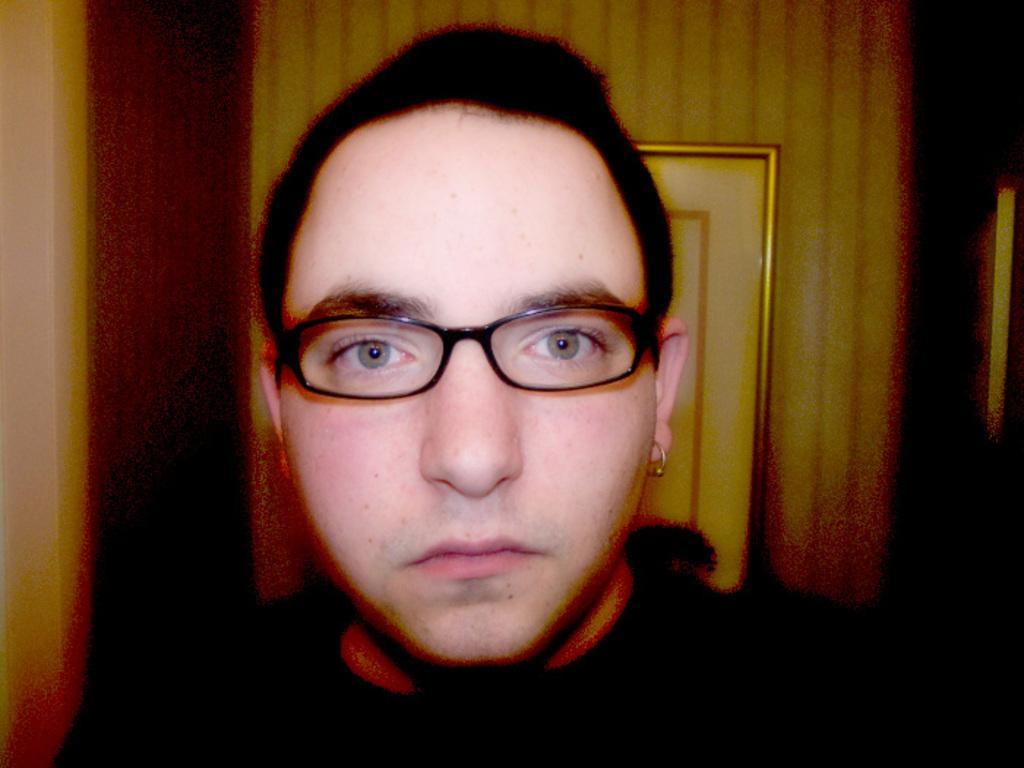Could you give a brief overview of what you see in this image? A person is present wearing spectacles and an earring. There is a photo frame at the back. 